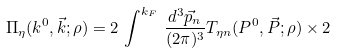Convert formula to latex. <formula><loc_0><loc_0><loc_500><loc_500>\Pi _ { \eta } ( k ^ { 0 } , \vec { k } ; \rho ) = 2 \, \int ^ { k _ { F } } \, \frac { d ^ { 3 } \vec { p } _ { n } } { ( 2 \pi ) ^ { 3 } } T _ { \eta n } ( P ^ { 0 } , \vec { P } ; \rho ) \times 2</formula> 